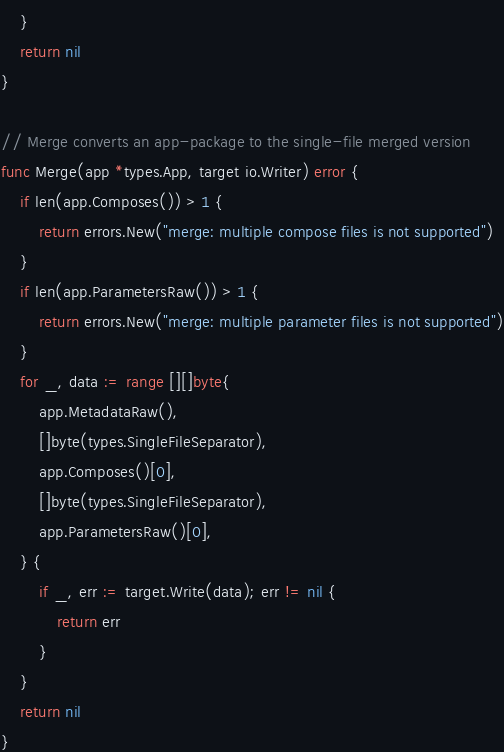Convert code to text. <code><loc_0><loc_0><loc_500><loc_500><_Go_>	}
	return nil
}

// Merge converts an app-package to the single-file merged version
func Merge(app *types.App, target io.Writer) error {
	if len(app.Composes()) > 1 {
		return errors.New("merge: multiple compose files is not supported")
	}
	if len(app.ParametersRaw()) > 1 {
		return errors.New("merge: multiple parameter files is not supported")
	}
	for _, data := range [][]byte{
		app.MetadataRaw(),
		[]byte(types.SingleFileSeparator),
		app.Composes()[0],
		[]byte(types.SingleFileSeparator),
		app.ParametersRaw()[0],
	} {
		if _, err := target.Write(data); err != nil {
			return err
		}
	}
	return nil
}
</code> 